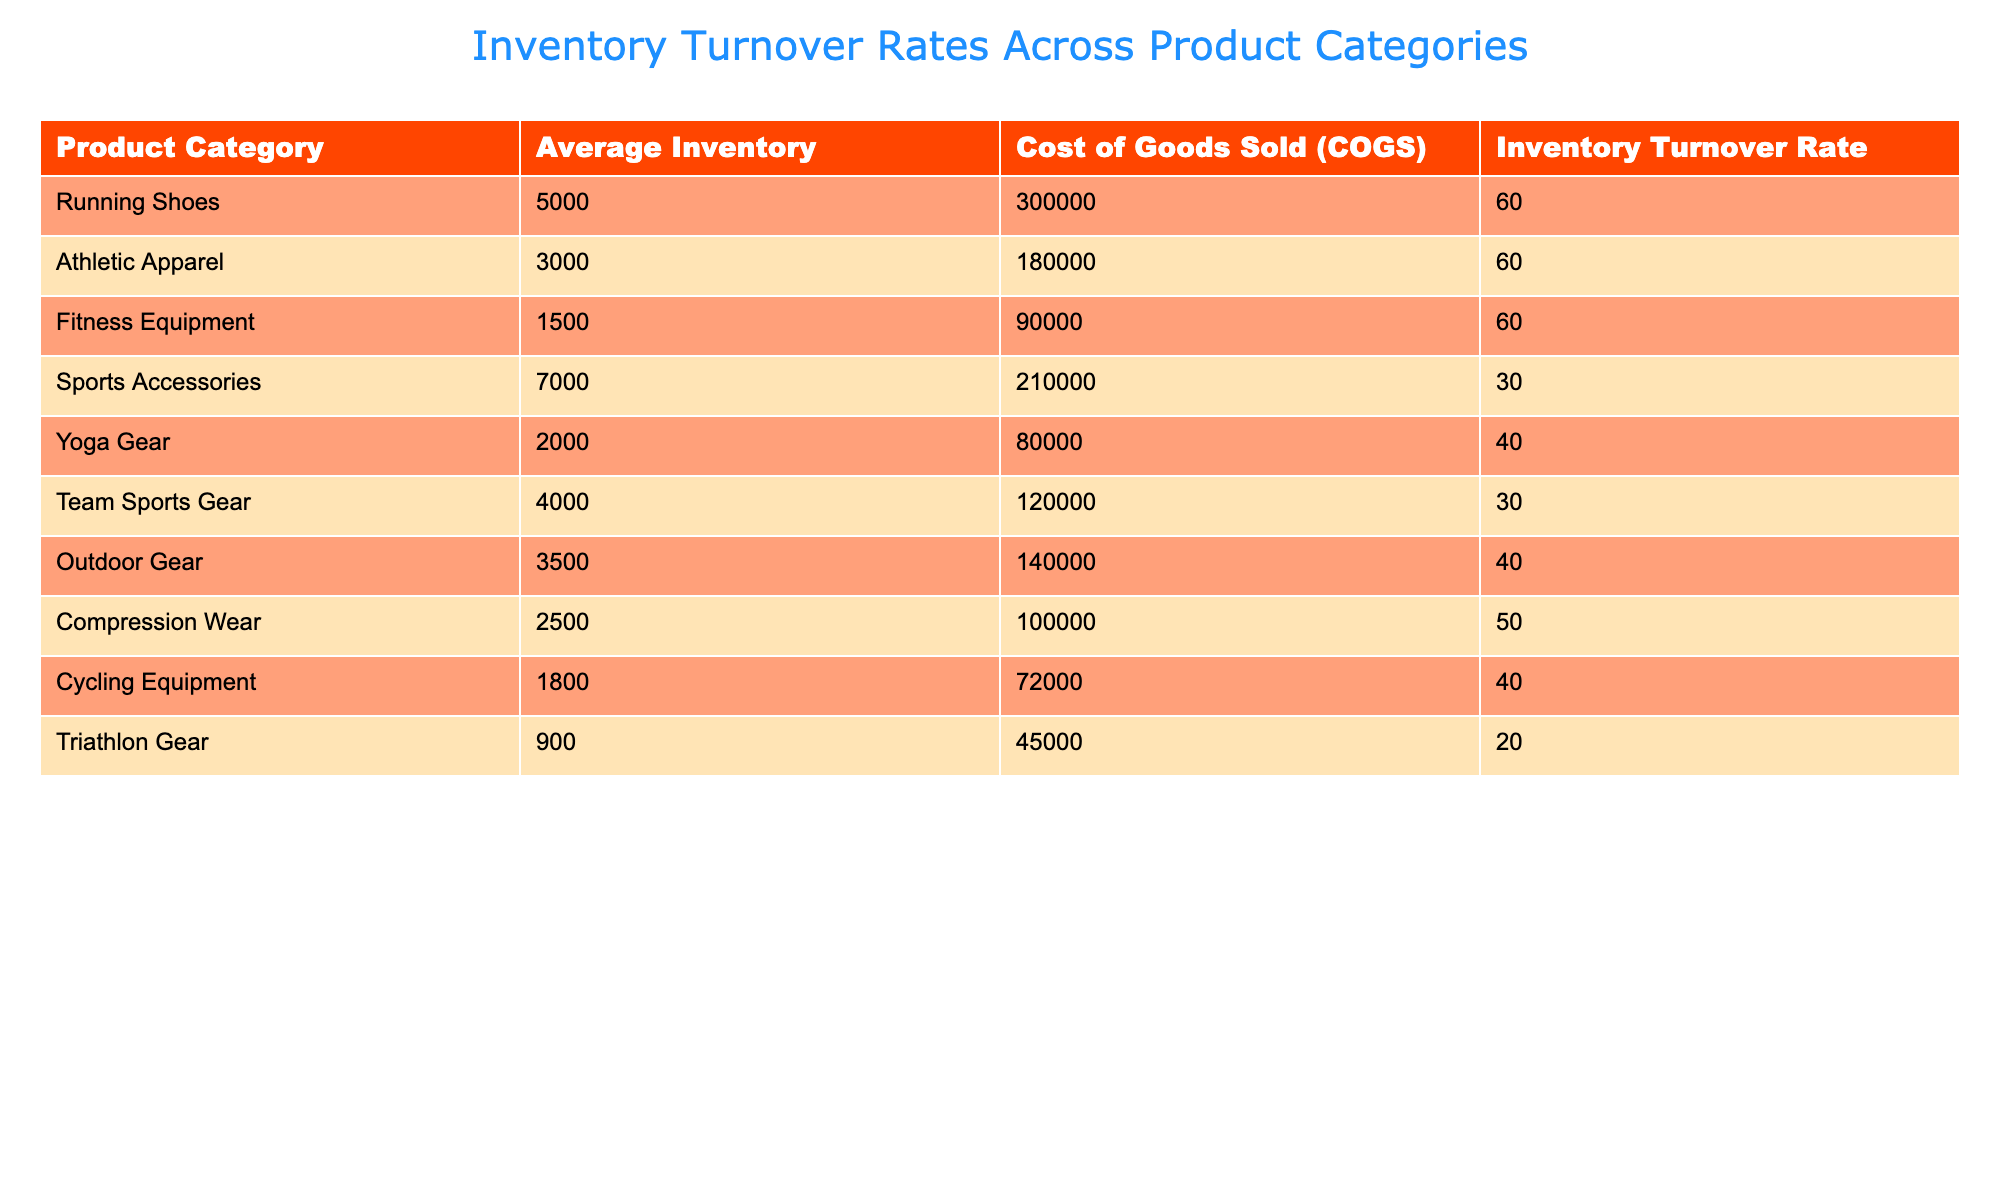What is the inventory turnover rate for Fitness Equipment? The table displays the inventory turnover rate for each product category. For Fitness Equipment, the corresponding value is directly listed in the table.
Answer: 60 Which product category has the highest average inventory? To find the product category with the highest average inventory, I compare the values listed under the Average Inventory column. The highest value is 7000, which corresponds to Sports Accessories.
Answer: Sports Accessories What is the total average inventory for all product categories combined? To get the total average inventory, I sum the average inventory for all product categories: 5000 + 3000 + 1500 + 7000 + 2000 + 4000 + 3500 + 2500 + 1800 + 900 = 22,200.
Answer: 22200 Are there any product categories with an inventory turnover rate below 30? I will check the Inventory Turnover Rate column for any values below 30. The only categories with a turnover rate of 30 or below are Sports Accessories (30) and Team Sports Gear (30). Since none are below 30, the answer is No.
Answer: No What is the difference in inventory turnover rates between Yoga Gear and Triathlon Gear? First, I identify the inventory turnover rates for both Yoga Gear (40) and Triathlon Gear (20). Next, I subtract the Triathlon Gear rate from the Yoga Gear rate: 40 - 20 = 20.
Answer: 20 How many product categories have an inventory turnover rate of exactly 60? I will look at the Inventory Turnover Rate column and count how many categories have a rate of 60. The categories Running Shoes and Athletic Apparel both have this rate, so there are 2 categories.
Answer: 2 What is the average inventory turnover rate across all product categories? I sum the inventory turnover rates of all categories: 60 + 60 + 60 + 30 + 40 + 30 + 40 + 50 + 40 + 20 = 430. There are 10 categories, so I divide: 430 / 10 = 43.
Answer: 43 Which product category has the lowest inventory turnover rate? By reviewing the Inventory Turnover Rate column, I can see the lowest value is 20, which corresponds to Triathlon Gear.
Answer: Triathlon Gear Is the average inventory of Compression Wear greater than that of Triathlon Gear? Looking at the Average Inventory column, Compression Wear shows 2500 while Triathlon Gear shows 900. Since 2500 is greater than 900, the answer is Yes.
Answer: Yes 